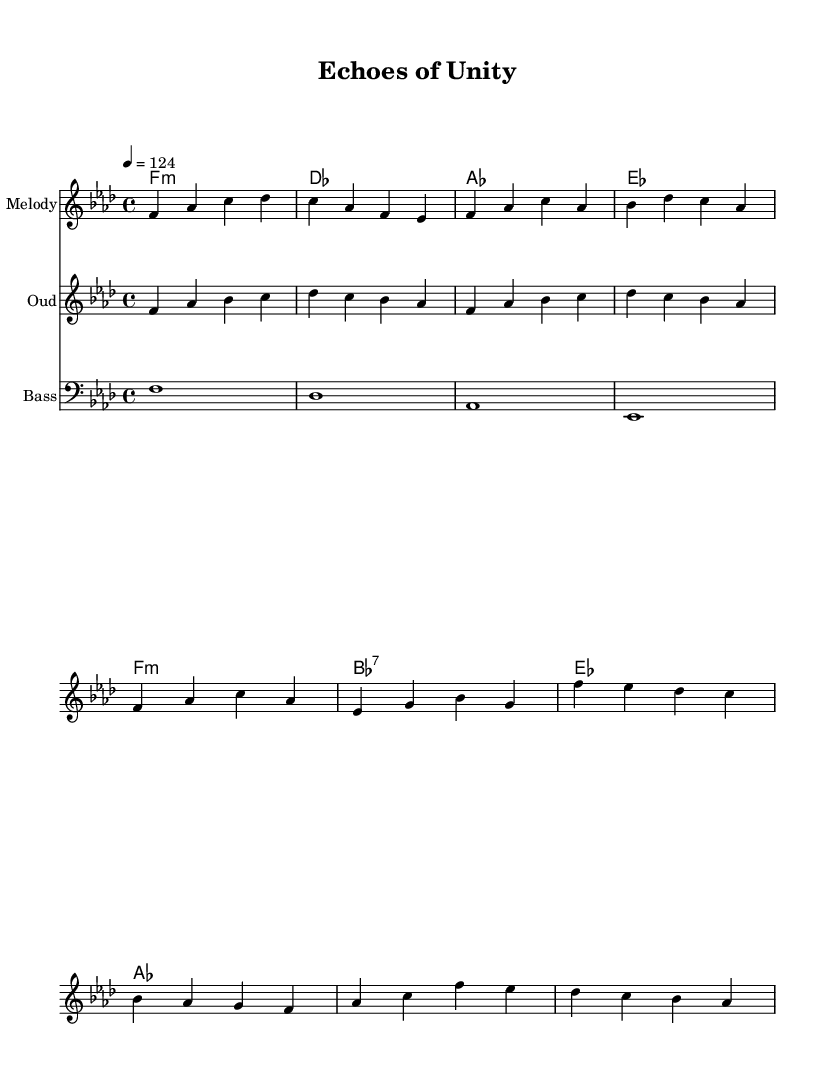What is the key signature of this music? The key signature is F minor, which includes four flats (B, E, A, and D). This information can be found in the key signature found at the beginning of the staff.
Answer: F minor What is the time signature of this music? The time signature is 4/4, indicated at the beginning of the score, telling us that there are four beats in each measure and the quarter note gets one beat.
Answer: 4/4 What is the tempo marking for this piece? The tempo marking is 124 beats per minute (bpm), specified at the beginning of the score with the indication "4 = 124". This means each quarter note is equivalent to 124 beats per minute.
Answer: 124 How many measures are in the melody? The melody contains 8 measures, which can be counted by looking at the bar lines separating the rhythmic groups in the melodic section.
Answer: 8 What instrument is indicated for the oud part? The instrument indicated for the oud part is labeled "Oud" in the score, showing that this staff is specifically for that instrument.
Answer: Oud Which chord is played in the first measure of the harmonies? The first measure of harmonies shows the chord F minor, denoted as "f1:m", specifying that it is a minor chord based on F.
Answer: F minor How many different chords are present in the harmonies? There are four different chords present in the harmonies: F minor, D flat, A flat, and E flat. These can be identified by analyzing each measure in the chord section.
Answer: 4 